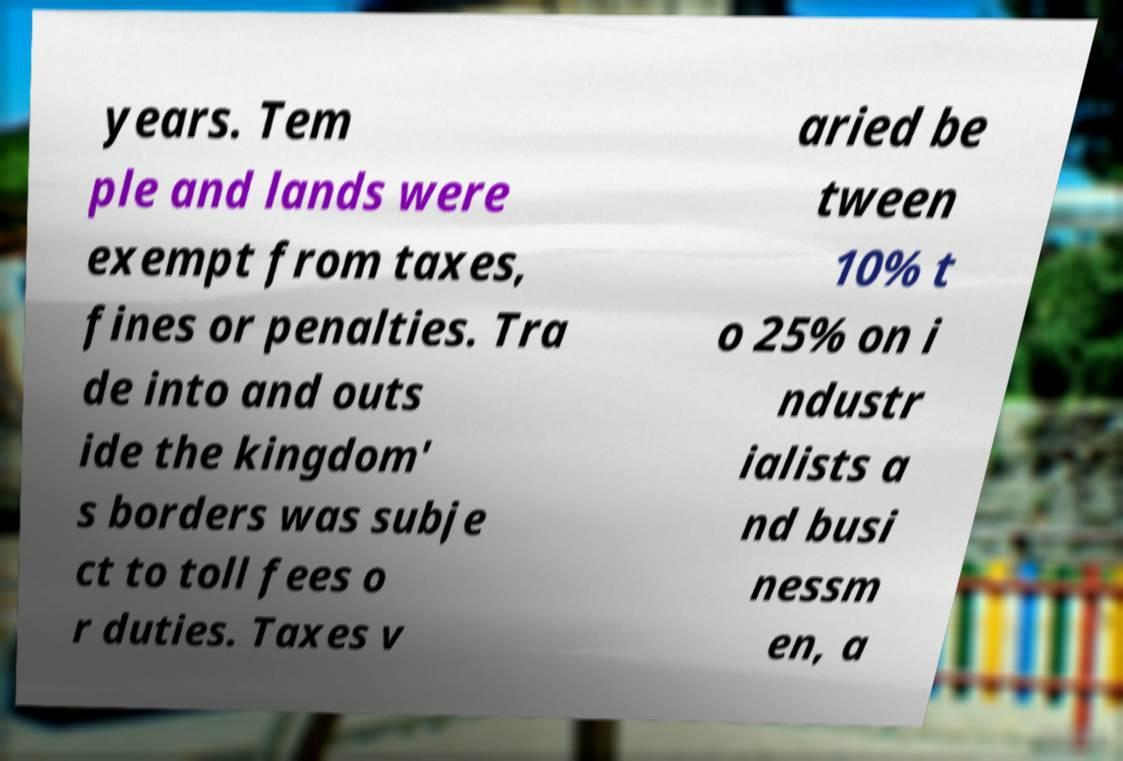Could you assist in decoding the text presented in this image and type it out clearly? years. Tem ple and lands were exempt from taxes, fines or penalties. Tra de into and outs ide the kingdom' s borders was subje ct to toll fees o r duties. Taxes v aried be tween 10% t o 25% on i ndustr ialists a nd busi nessm en, a 